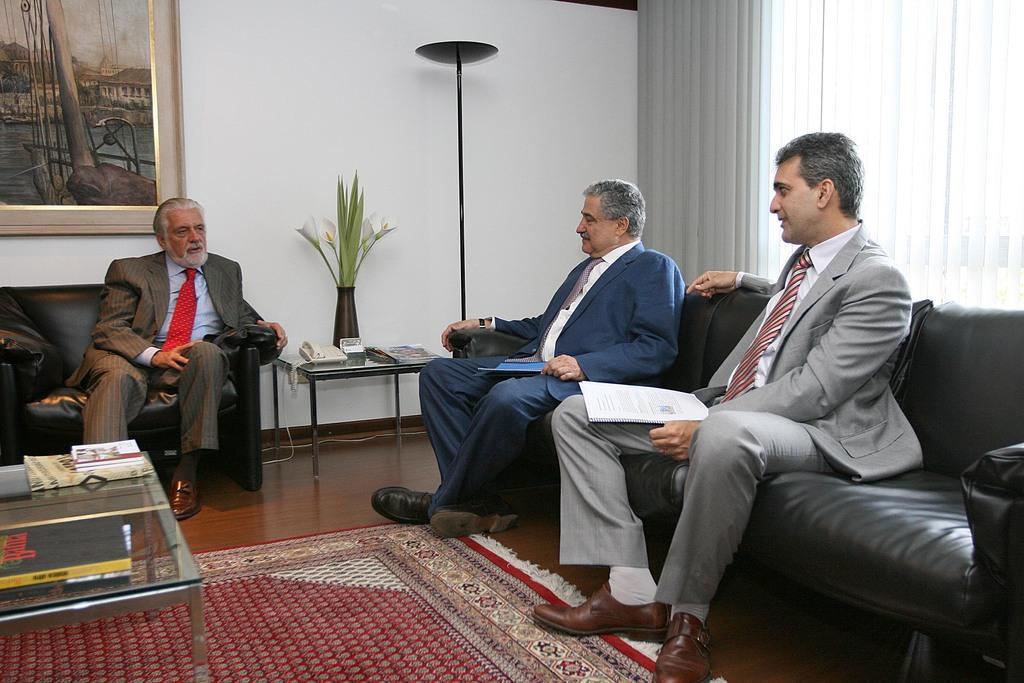In one or two sentences, can you explain what this image depicts? In the center of the picture there is a couch, on the couch there are two people sitting. In the center of the background there are flowers, lamp, telephone, paper, cable and a desk. On the right there is a window and a window blind. On the left there are desk, couch and a frame. On the desk there are books. On the couch there is a man sitting. 